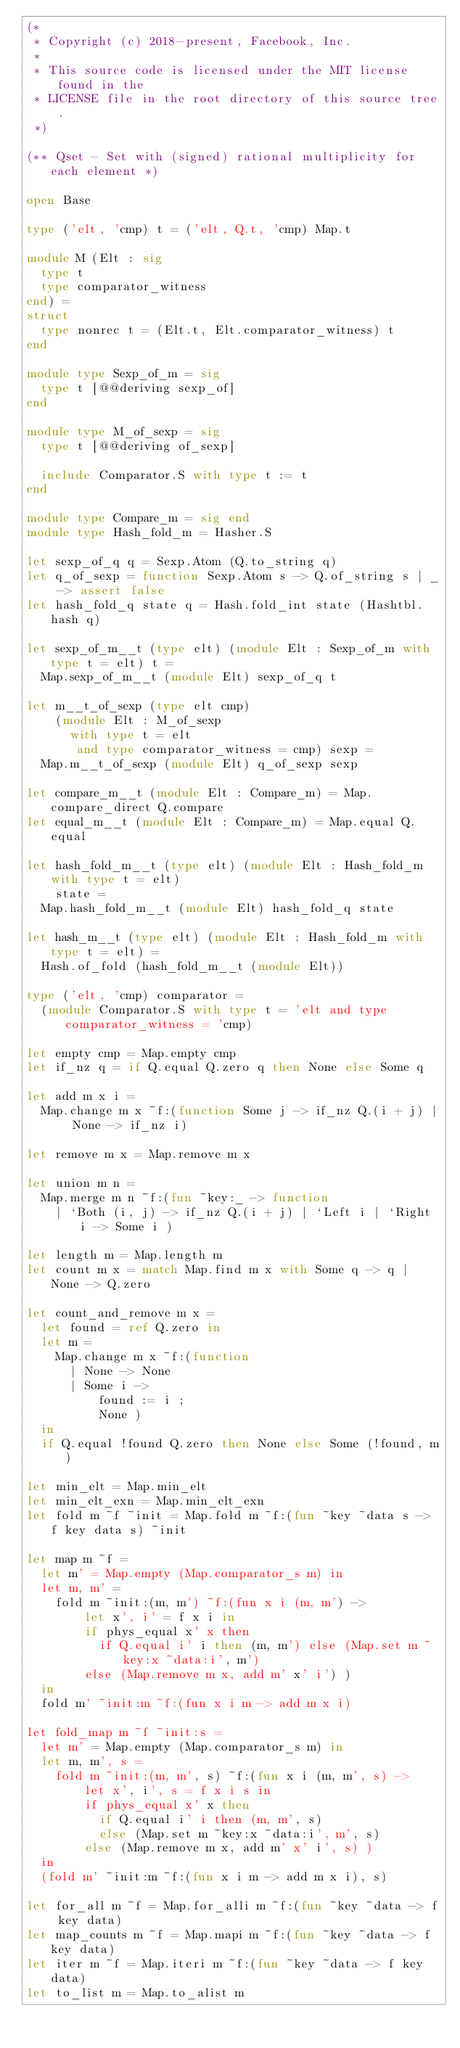<code> <loc_0><loc_0><loc_500><loc_500><_OCaml_>(*
 * Copyright (c) 2018-present, Facebook, Inc.
 *
 * This source code is licensed under the MIT license found in the
 * LICENSE file in the root directory of this source tree.
 *)

(** Qset - Set with (signed) rational multiplicity for each element *)

open Base

type ('elt, 'cmp) t = ('elt, Q.t, 'cmp) Map.t

module M (Elt : sig
  type t
  type comparator_witness
end) =
struct
  type nonrec t = (Elt.t, Elt.comparator_witness) t
end

module type Sexp_of_m = sig
  type t [@@deriving sexp_of]
end

module type M_of_sexp = sig
  type t [@@deriving of_sexp]

  include Comparator.S with type t := t
end

module type Compare_m = sig end
module type Hash_fold_m = Hasher.S

let sexp_of_q q = Sexp.Atom (Q.to_string q)
let q_of_sexp = function Sexp.Atom s -> Q.of_string s | _ -> assert false
let hash_fold_q state q = Hash.fold_int state (Hashtbl.hash q)

let sexp_of_m__t (type elt) (module Elt : Sexp_of_m with type t = elt) t =
  Map.sexp_of_m__t (module Elt) sexp_of_q t

let m__t_of_sexp (type elt cmp)
    (module Elt : M_of_sexp
      with type t = elt
       and type comparator_witness = cmp) sexp =
  Map.m__t_of_sexp (module Elt) q_of_sexp sexp

let compare_m__t (module Elt : Compare_m) = Map.compare_direct Q.compare
let equal_m__t (module Elt : Compare_m) = Map.equal Q.equal

let hash_fold_m__t (type elt) (module Elt : Hash_fold_m with type t = elt)
    state =
  Map.hash_fold_m__t (module Elt) hash_fold_q state

let hash_m__t (type elt) (module Elt : Hash_fold_m with type t = elt) =
  Hash.of_fold (hash_fold_m__t (module Elt))

type ('elt, 'cmp) comparator =
  (module Comparator.S with type t = 'elt and type comparator_witness = 'cmp)

let empty cmp = Map.empty cmp
let if_nz q = if Q.equal Q.zero q then None else Some q

let add m x i =
  Map.change m x ~f:(function Some j -> if_nz Q.(i + j) | None -> if_nz i)

let remove m x = Map.remove m x

let union m n =
  Map.merge m n ~f:(fun ~key:_ -> function
    | `Both (i, j) -> if_nz Q.(i + j) | `Left i | `Right i -> Some i )

let length m = Map.length m
let count m x = match Map.find m x with Some q -> q | None -> Q.zero

let count_and_remove m x =
  let found = ref Q.zero in
  let m =
    Map.change m x ~f:(function
      | None -> None
      | Some i ->
          found := i ;
          None )
  in
  if Q.equal !found Q.zero then None else Some (!found, m)

let min_elt = Map.min_elt
let min_elt_exn = Map.min_elt_exn
let fold m ~f ~init = Map.fold m ~f:(fun ~key ~data s -> f key data s) ~init

let map m ~f =
  let m' = Map.empty (Map.comparator_s m) in
  let m, m' =
    fold m ~init:(m, m') ~f:(fun x i (m, m') ->
        let x', i' = f x i in
        if phys_equal x' x then
          if Q.equal i' i then (m, m') else (Map.set m ~key:x ~data:i', m')
        else (Map.remove m x, add m' x' i') )
  in
  fold m' ~init:m ~f:(fun x i m -> add m x i)

let fold_map m ~f ~init:s =
  let m' = Map.empty (Map.comparator_s m) in
  let m, m', s =
    fold m ~init:(m, m', s) ~f:(fun x i (m, m', s) ->
        let x', i', s = f x i s in
        if phys_equal x' x then
          if Q.equal i' i then (m, m', s)
          else (Map.set m ~key:x ~data:i', m', s)
        else (Map.remove m x, add m' x' i', s) )
  in
  (fold m' ~init:m ~f:(fun x i m -> add m x i), s)

let for_all m ~f = Map.for_alli m ~f:(fun ~key ~data -> f key data)
let map_counts m ~f = Map.mapi m ~f:(fun ~key ~data -> f key data)
let iter m ~f = Map.iteri m ~f:(fun ~key ~data -> f key data)
let to_list m = Map.to_alist m
</code> 